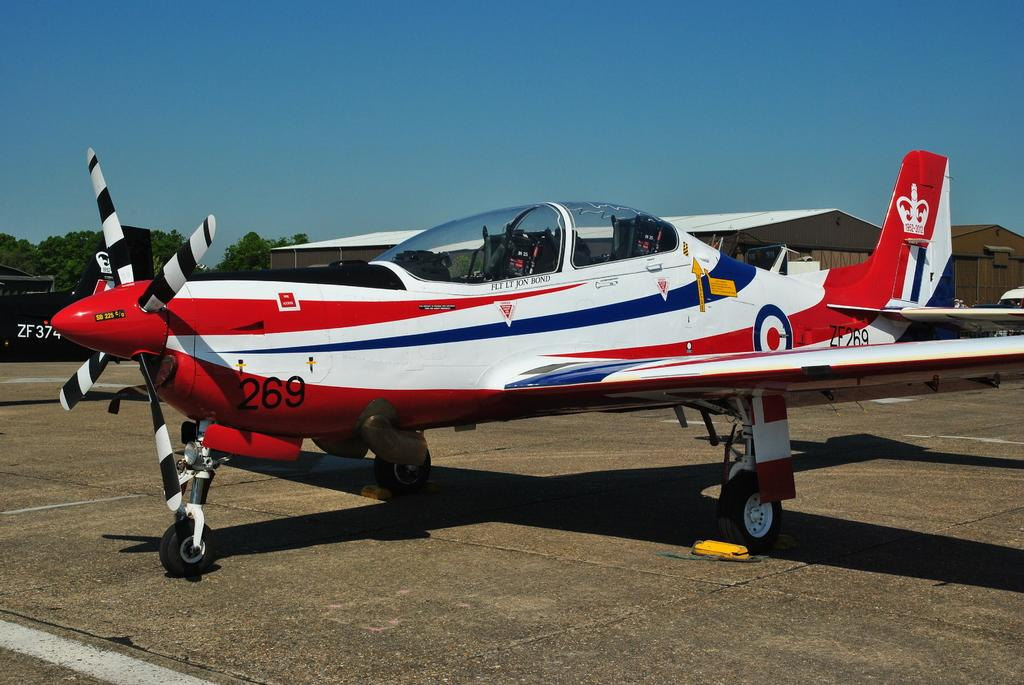What is the main subject in the center of the image? There is an aeroplane in the center of the image. What can be seen in the background of the image? There are buildings, trees, and the sky visible in the background of the image. How much is the payment for the train ticket in the image? There are no trains or tickets present in the image; it features an aeroplane and background elements. 